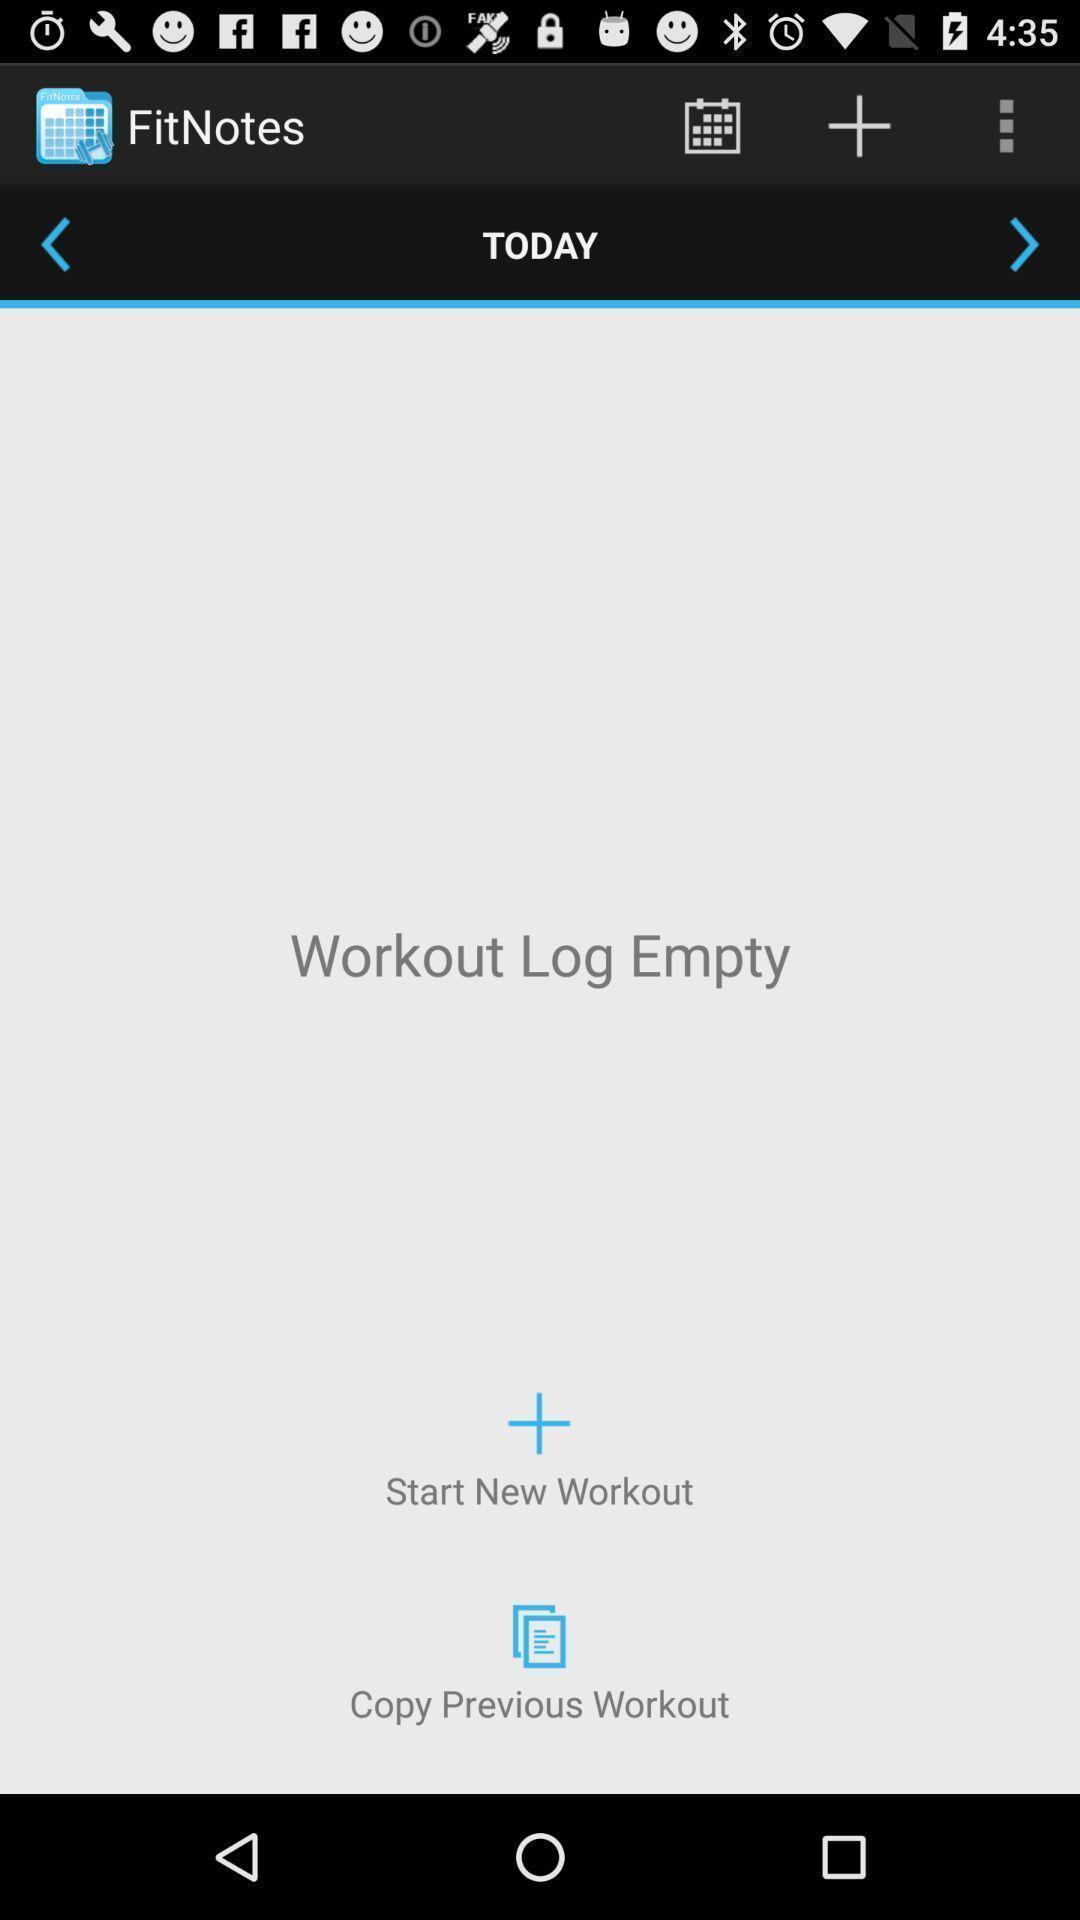Tell me what you see in this picture. Social app for showing notes. 